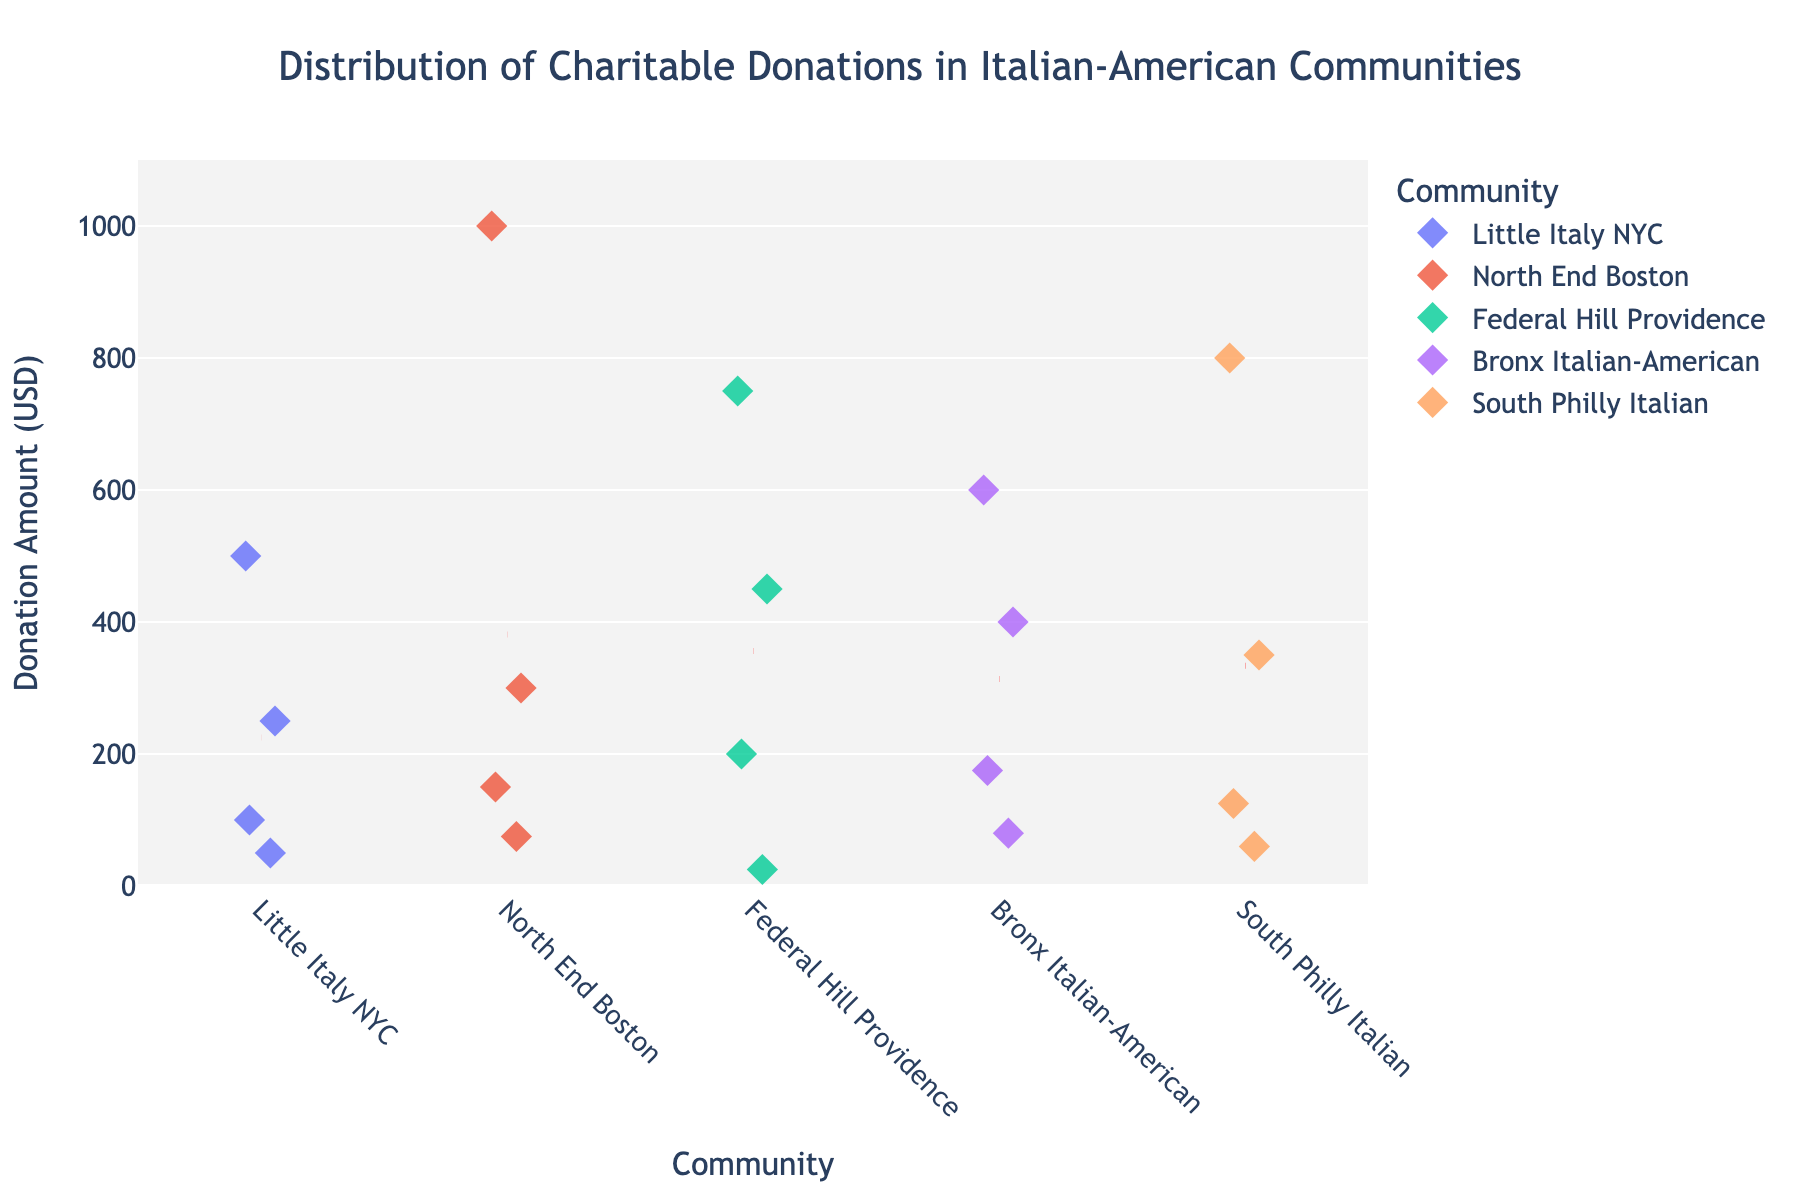What is the title of the plot? The title of the plot is usually prominently displayed at the top of the figure. It provides a summary of what the graph is about. Here, it should describe the distribution of charitable donations.
Answer: Distribution of Charitable Donations in Italian-American Communities Which community has the highest single donation amount? To find this, observe the y-axis values for each community and identify the highest point. In this case, the highest donation amount is $1000, which is associated with North End Boston.
Answer: North End Boston What is the mean donation amount for Little Italy NYC? The mean donation amount is represented by the red dashed line for Little Italy NYC. Visually locate this line intersecting the y-axis and read the corresponding value.
Answer: $225 How many different charitable donation amounts are recorded for South Philly Italian? Count the number of diamond markers (data points) shown along the x-axis for the community "South Philly Italian".
Answer: 4 Among the listed communities, which one has the most varied donation amounts? To determine this, observe the spread of the diamond markers along the y-axis for each community. The wider the spread, the more varied the donations. North End Boston shows the most varied donations ranging from $75 to $1000.
Answer: North End Boston What is the range of donation amounts for Federal Hill Providence? Range is the difference between the highest and lowest values. For Federal Hill Providence, the highest amount is $750 and the lowest is $25. So, the range is calculated as $750 - $25.
Answer: $725 How many communities have a mean donation amount below $300? Identify the red dashed lines for the communities and check which ones fall below the $300 mark on the y-axis. "Little Italy NYC" and "Federal Hill Providence" are below $300.
Answer: 2 Which community's donation amounts are clustered within the $100 to $500 range? Identify the community whose diamond markers mostly fall within the $100 to $500 range on the y-axis. "Bronx Italian-American" donations are clustered within this range.
Answer: Bronx Italian-American What is the most common donation amount for Little Italy NYC, and where is its position on the y-axis? Observe the clustering of diamond markers to find the most recurring value. For Little Italy NYC, $100 is the most common amount as it has the highest concentration of data points.
Answer: $100 Which community has a more concentrated donation pattern, Bronx Italian-American or South Philly Italian? Compare the spread of diamond markers for both communities. "Bronx Italian-American" has a denser concentration of markers compared to "South Philly Italian".
Answer: Bronx Italian-American 